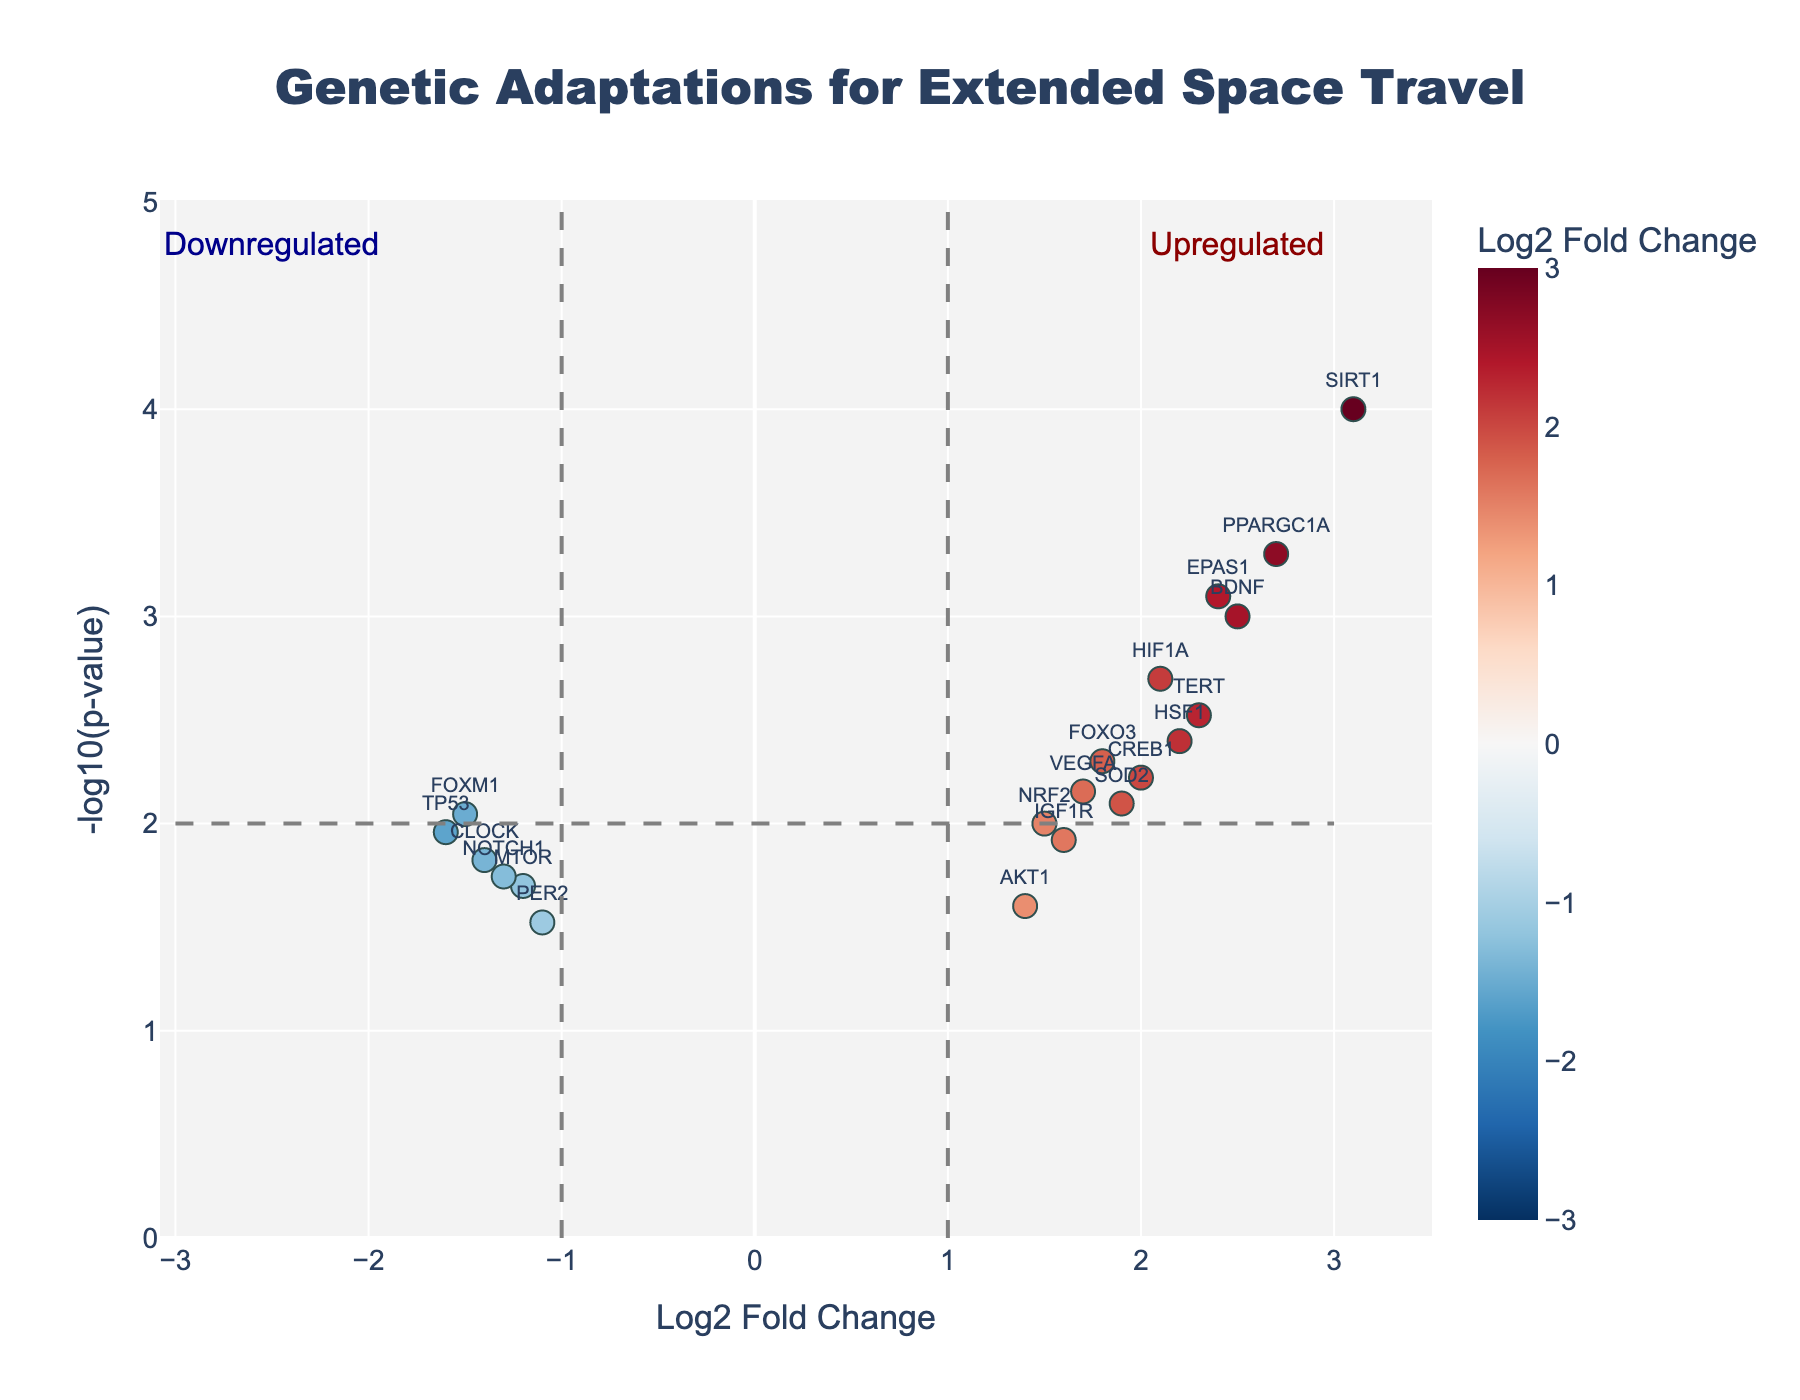What's the title of the volcano plot? The title is located at the top of the figure. It summarizes the main topic or focus of the plot.
Answer: Genetic Adaptations for Extended Space Travel What are the axes labeled? The axes' labels provide information about what each axis represents. The x-axis represents "Log2 Fold Change," and the y-axis represents "-log10(p-value)."
Answer: Log2 Fold Change and -log10(p-value) How many genes are shown in the plot? To find the number of genes shown, count the data points in the plot. Each point represents a gene. Since each gene in the provided data has a corresponding point, there are 20 genes.
Answer: 20 Which gene has the highest Log2 fold change and what is its value? To find this, identify the gene with the highest positive value on the x-axis. According to the data, SIRT1 has the highest Log2 fold change, which is 3.1.
Answer: SIRT1, 3.1 Which gene has the lowest Log2 fold change and what is its value? This can be determined by finding the gene with the most negative value on the x-axis. The gene FOXM1 has the lowest Log2 fold change, which is -1.5.
Answer: FOXM1, -1.5 How many genes are upregulated? Upregulated genes will have a positive Log2 fold change. Count the number of data points on the right side of the plot's center (x=0). In this case, there are 14 such genes.
Answer: 14 What gene has the smallest (most significant) P-value, and what is its P-value? The most significant P-value will have the highest -log10(p-value) on the y-axis. According to the data, the gene SIRT1 has the smallest P-value, which is 0.0001.
Answer: SIRT1, 0.0001 Which genes are downregulated and have a P-value less than 0.02? Downregulated genes have a negative Log2 fold change, and we need to find those with a P-value < 0.02. The genes are CLOCK (P-value = 0.015), NOTCH1 (P-value = 0.018), and TP53 (P-value = 0.011).
Answer: CLOCK, NOTCH1, TP53 Compare the Log2 fold change of BDNF and HIF1A. Which one is higher, and by how much? Look at the Log2 fold change values for BDNF (2.5) and HIF1A (2.1). Subtract the smaller value from the larger value: 2.5 - 2.1 = 0.4. Hence, BDNF is higher by 0.4.
Answer: BDNF is higher by 0.4 For the genes VEGFA and PER2, which has a higher p-value? Refer to the y-axis for -log10(p-value) to determine this. VEGFA has a -log10(p-value) of approximately 2.15, and PER2 has -log10(p-value) of approximately 1.52. The gene with the lower -log10(p-value) has the higher P-value.
Answer: PER2 